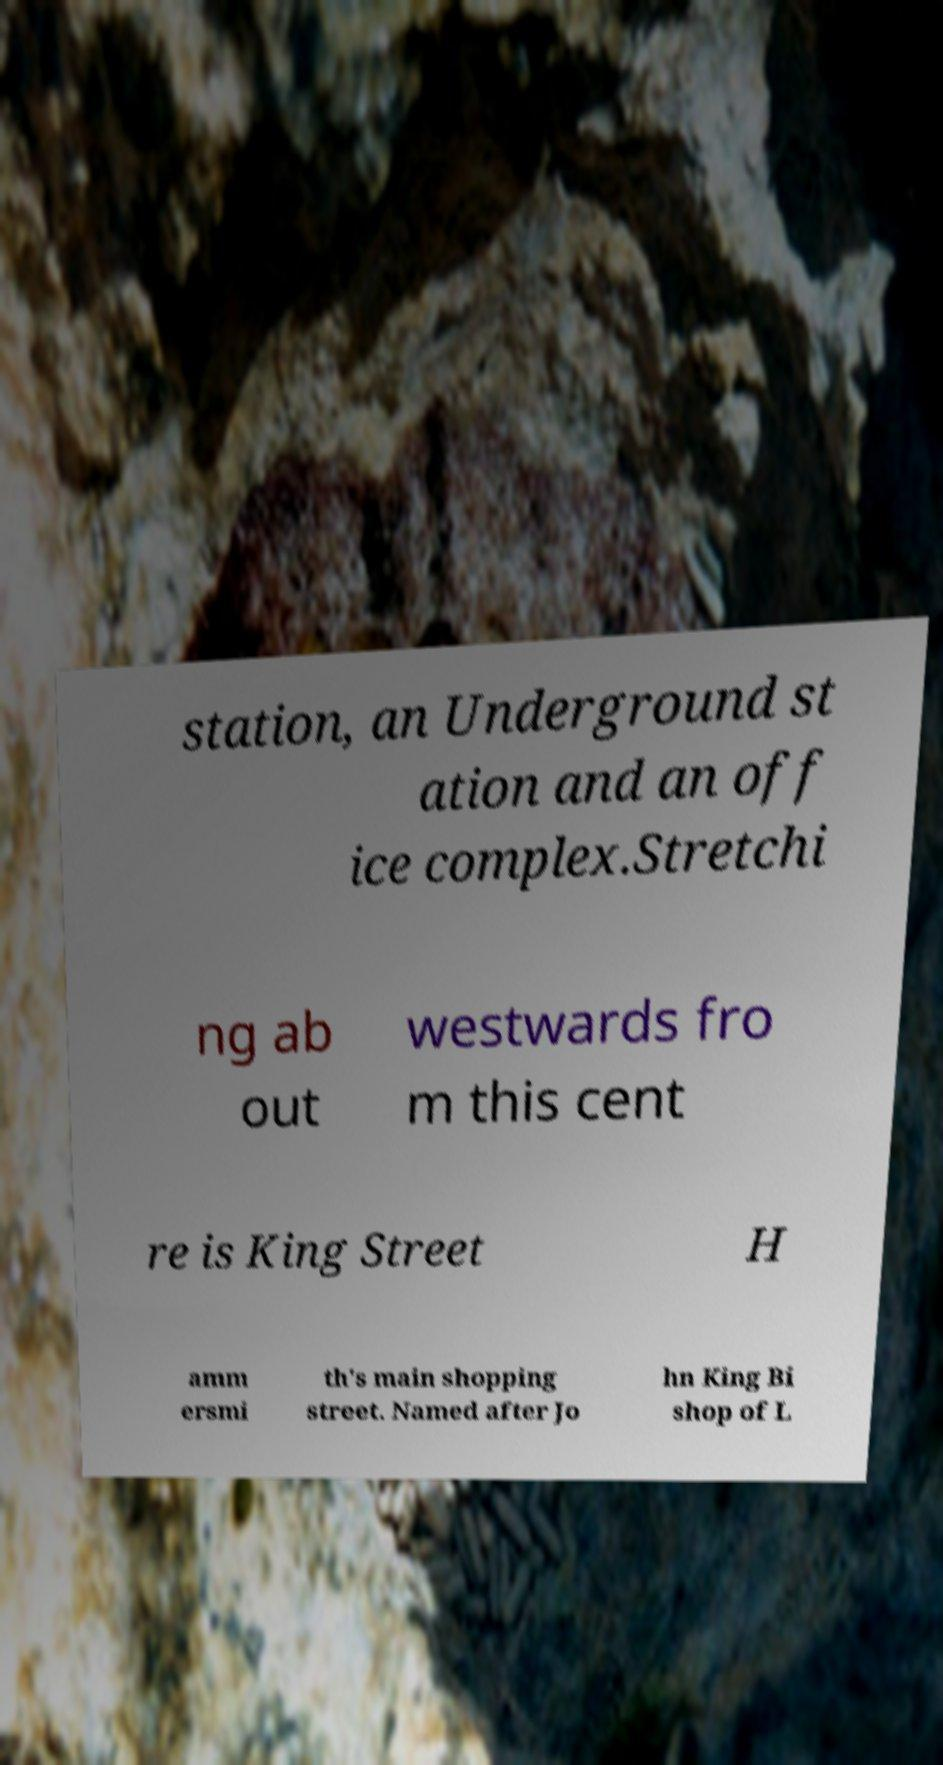I need the written content from this picture converted into text. Can you do that? station, an Underground st ation and an off ice complex.Stretchi ng ab out westwards fro m this cent re is King Street H amm ersmi th's main shopping street. Named after Jo hn King Bi shop of L 